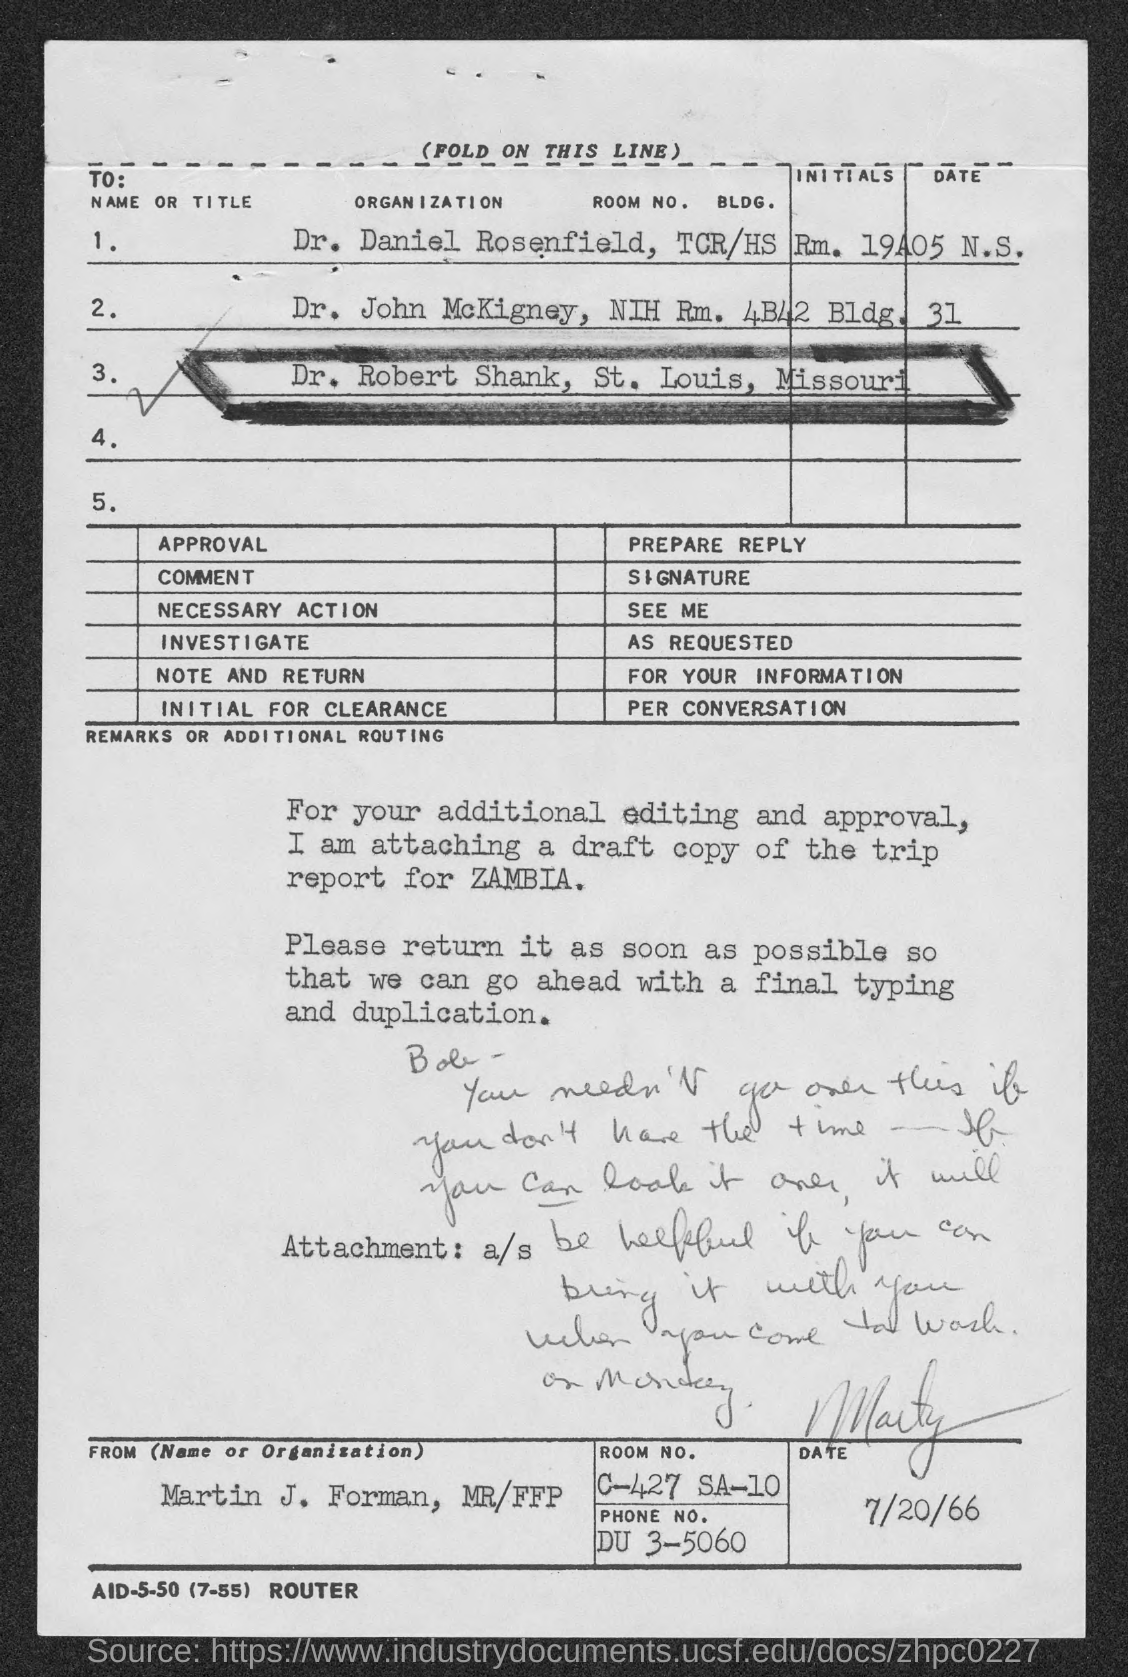List a handful of essential elements in this visual. The room number of Martin J. Forman, MR/FFP, is C-427 SA-10. The phone number of Martin J. Forman, MR/FFP, is DU 3-5060. The sender of this document is Martin J. Forman, who signed it with the abbreviation MR/FFP. 